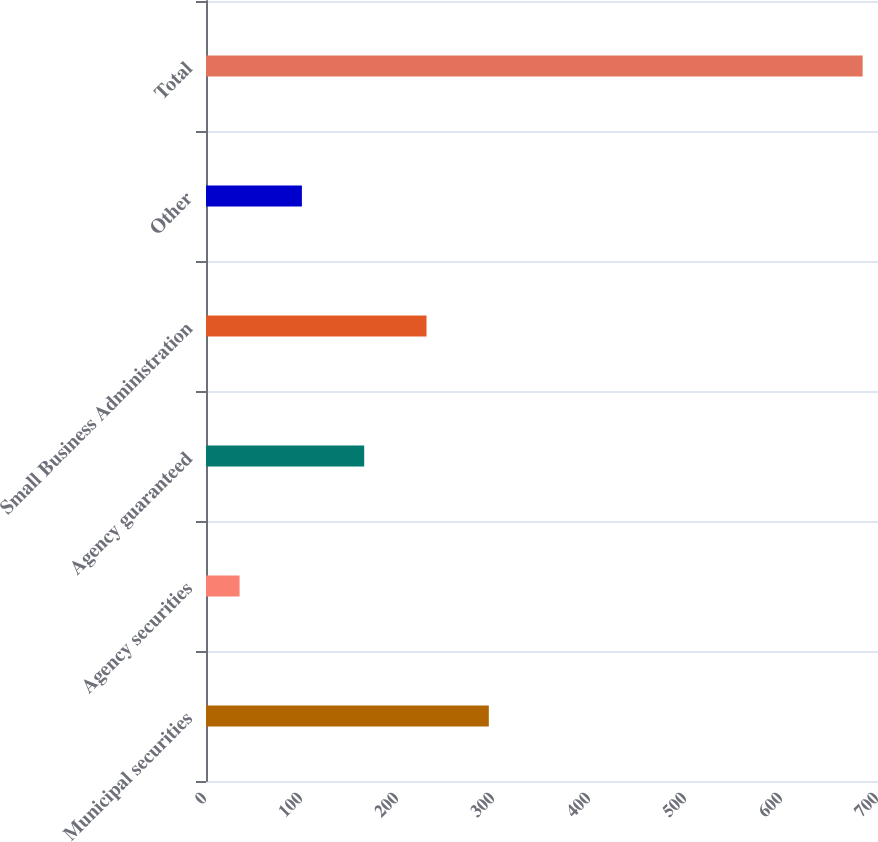<chart> <loc_0><loc_0><loc_500><loc_500><bar_chart><fcel>Municipal securities<fcel>Agency securities<fcel>Agency guaranteed<fcel>Small Business Administration<fcel>Other<fcel>Total<nl><fcel>294.6<fcel>35<fcel>164.8<fcel>229.7<fcel>99.9<fcel>684<nl></chart> 